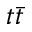<formula> <loc_0><loc_0><loc_500><loc_500>t \bar { t }</formula> 